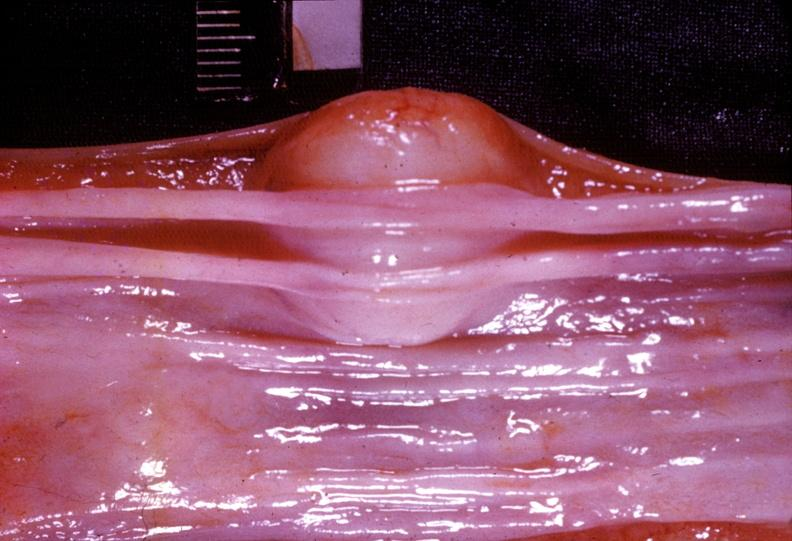s intraductal papillomatosis present?
Answer the question using a single word or phrase. No 